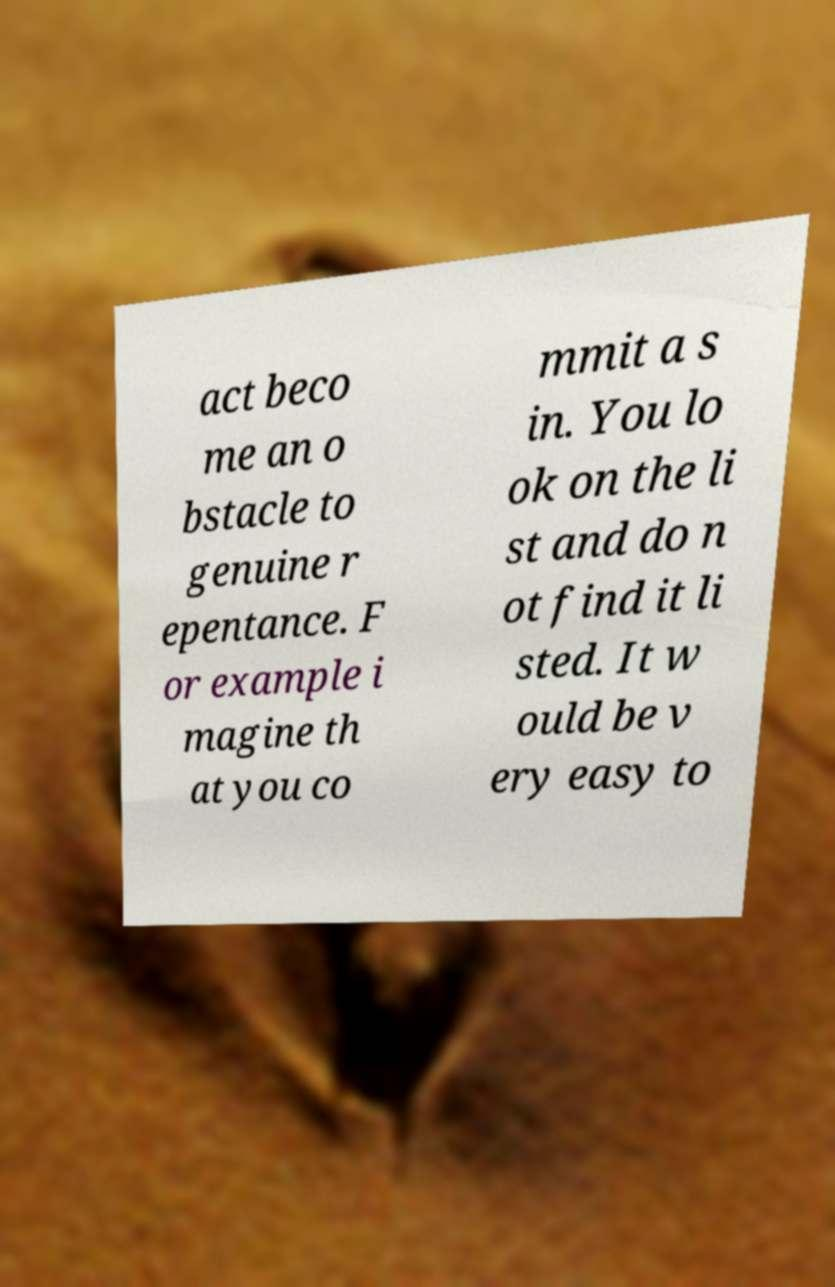Can you accurately transcribe the text from the provided image for me? act beco me an o bstacle to genuine r epentance. F or example i magine th at you co mmit a s in. You lo ok on the li st and do n ot find it li sted. It w ould be v ery easy to 